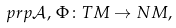<formula> <loc_0><loc_0><loc_500><loc_500>\ p r p \mathcal { A } , \, \Phi \colon T M \rightarrow N M ,</formula> 